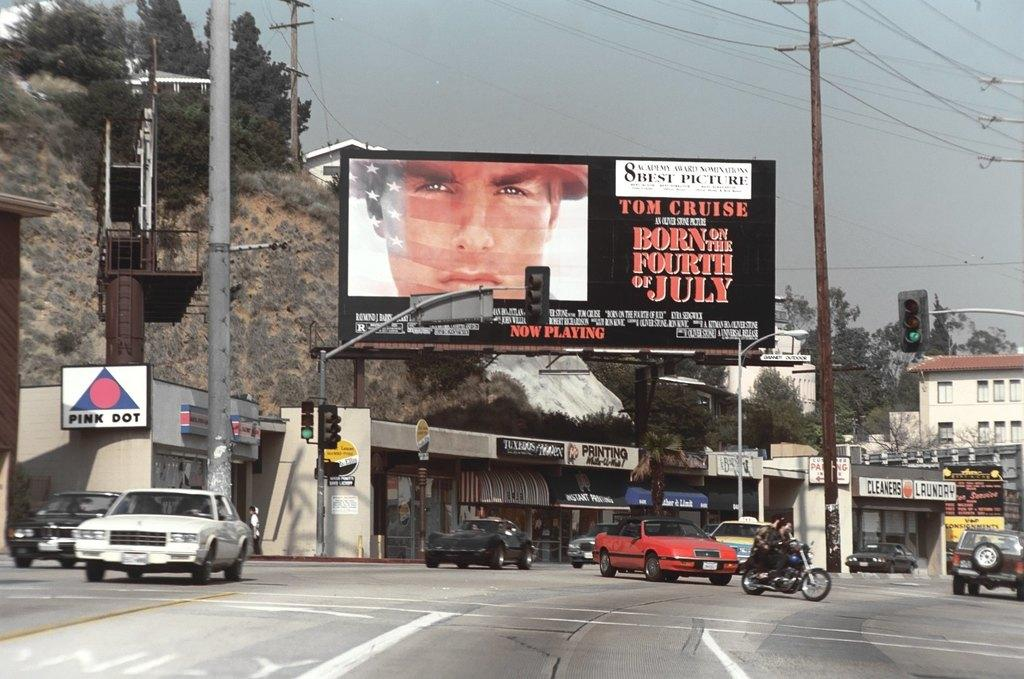<image>
Create a compact narrative representing the image presented. A billboard is posted for Tom Cruise in Born on the Fourth of July. 